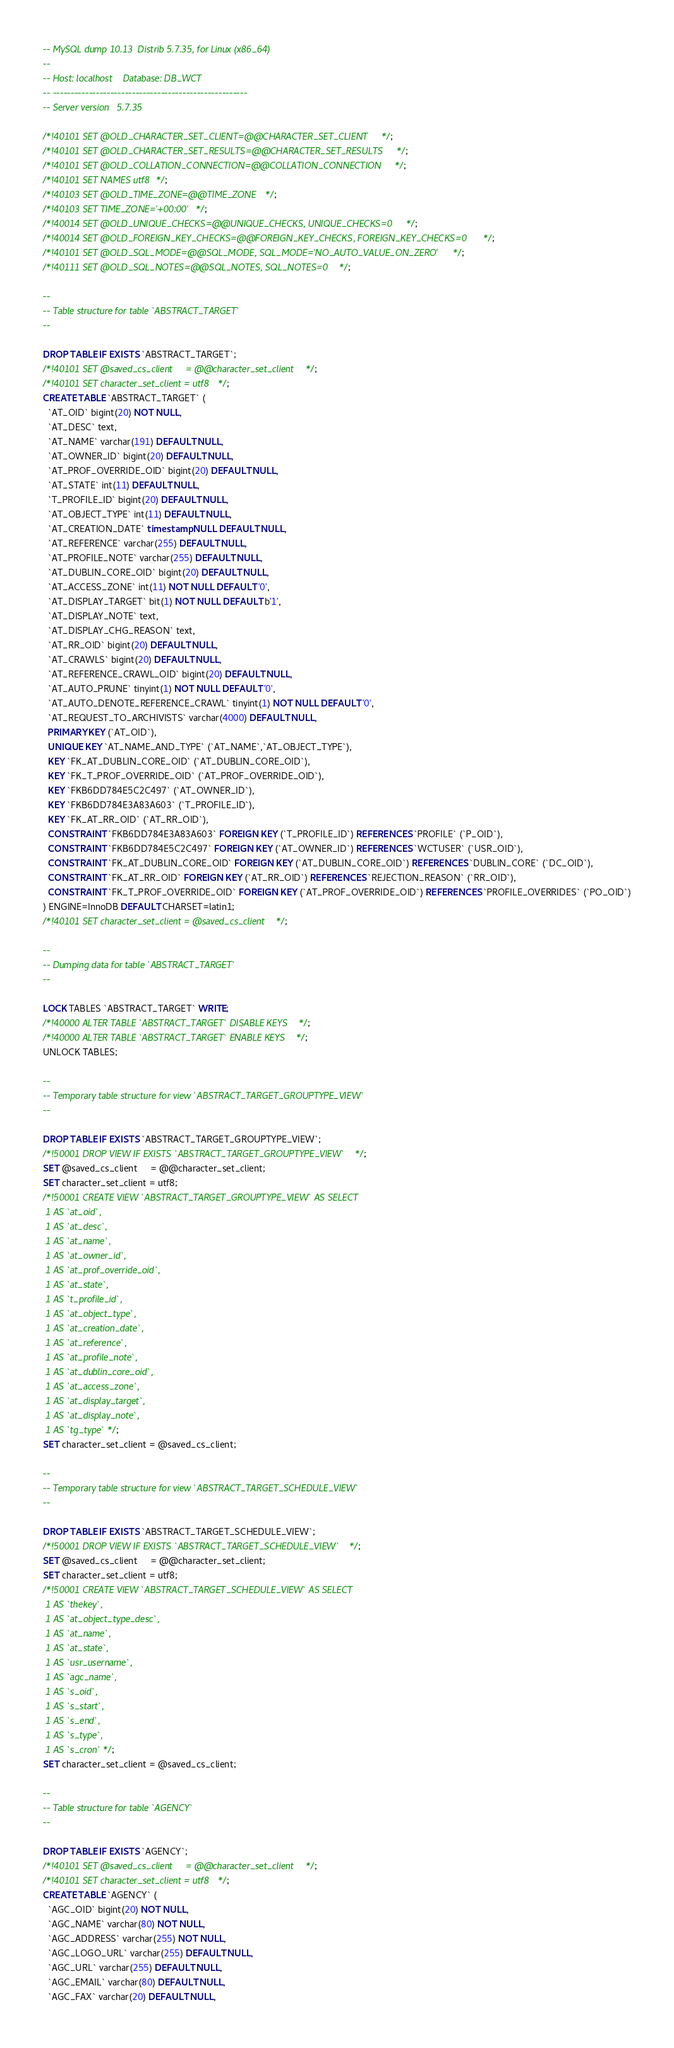Convert code to text. <code><loc_0><loc_0><loc_500><loc_500><_SQL_>-- MySQL dump 10.13  Distrib 5.7.35, for Linux (x86_64)
--
-- Host: localhost    Database: DB_WCT
-- ------------------------------------------------------
-- Server version	5.7.35

/*!40101 SET @OLD_CHARACTER_SET_CLIENT=@@CHARACTER_SET_CLIENT */;
/*!40101 SET @OLD_CHARACTER_SET_RESULTS=@@CHARACTER_SET_RESULTS */;
/*!40101 SET @OLD_COLLATION_CONNECTION=@@COLLATION_CONNECTION */;
/*!40101 SET NAMES utf8 */;
/*!40103 SET @OLD_TIME_ZONE=@@TIME_ZONE */;
/*!40103 SET TIME_ZONE='+00:00' */;
/*!40014 SET @OLD_UNIQUE_CHECKS=@@UNIQUE_CHECKS, UNIQUE_CHECKS=0 */;
/*!40014 SET @OLD_FOREIGN_KEY_CHECKS=@@FOREIGN_KEY_CHECKS, FOREIGN_KEY_CHECKS=0 */;
/*!40101 SET @OLD_SQL_MODE=@@SQL_MODE, SQL_MODE='NO_AUTO_VALUE_ON_ZERO' */;
/*!40111 SET @OLD_SQL_NOTES=@@SQL_NOTES, SQL_NOTES=0 */;

--
-- Table structure for table `ABSTRACT_TARGET`
--

DROP TABLE IF EXISTS `ABSTRACT_TARGET`;
/*!40101 SET @saved_cs_client     = @@character_set_client */;
/*!40101 SET character_set_client = utf8 */;
CREATE TABLE `ABSTRACT_TARGET` (
  `AT_OID` bigint(20) NOT NULL,
  `AT_DESC` text,
  `AT_NAME` varchar(191) DEFAULT NULL,
  `AT_OWNER_ID` bigint(20) DEFAULT NULL,
  `AT_PROF_OVERRIDE_OID` bigint(20) DEFAULT NULL,
  `AT_STATE` int(11) DEFAULT NULL,
  `T_PROFILE_ID` bigint(20) DEFAULT NULL,
  `AT_OBJECT_TYPE` int(11) DEFAULT NULL,
  `AT_CREATION_DATE` timestamp NULL DEFAULT NULL,
  `AT_REFERENCE` varchar(255) DEFAULT NULL,
  `AT_PROFILE_NOTE` varchar(255) DEFAULT NULL,
  `AT_DUBLIN_CORE_OID` bigint(20) DEFAULT NULL,
  `AT_ACCESS_ZONE` int(11) NOT NULL DEFAULT '0',
  `AT_DISPLAY_TARGET` bit(1) NOT NULL DEFAULT b'1',
  `AT_DISPLAY_NOTE` text,
  `AT_DISPLAY_CHG_REASON` text,
  `AT_RR_OID` bigint(20) DEFAULT NULL,
  `AT_CRAWLS` bigint(20) DEFAULT NULL,
  `AT_REFERENCE_CRAWL_OID` bigint(20) DEFAULT NULL,
  `AT_AUTO_PRUNE` tinyint(1) NOT NULL DEFAULT '0',
  `AT_AUTO_DENOTE_REFERENCE_CRAWL` tinyint(1) NOT NULL DEFAULT '0',
  `AT_REQUEST_TO_ARCHIVISTS` varchar(4000) DEFAULT NULL,
  PRIMARY KEY (`AT_OID`),
  UNIQUE KEY `AT_NAME_AND_TYPE` (`AT_NAME`,`AT_OBJECT_TYPE`),
  KEY `FK_AT_DUBLIN_CORE_OID` (`AT_DUBLIN_CORE_OID`),
  KEY `FK_T_PROF_OVERRIDE_OID` (`AT_PROF_OVERRIDE_OID`),
  KEY `FKB6DD784E5C2C497` (`AT_OWNER_ID`),
  KEY `FKB6DD784E3A83A603` (`T_PROFILE_ID`),
  KEY `FK_AT_RR_OID` (`AT_RR_OID`),
  CONSTRAINT `FKB6DD784E3A83A603` FOREIGN KEY (`T_PROFILE_ID`) REFERENCES `PROFILE` (`P_OID`),
  CONSTRAINT `FKB6DD784E5C2C497` FOREIGN KEY (`AT_OWNER_ID`) REFERENCES `WCTUSER` (`USR_OID`),
  CONSTRAINT `FK_AT_DUBLIN_CORE_OID` FOREIGN KEY (`AT_DUBLIN_CORE_OID`) REFERENCES `DUBLIN_CORE` (`DC_OID`),
  CONSTRAINT `FK_AT_RR_OID` FOREIGN KEY (`AT_RR_OID`) REFERENCES `REJECTION_REASON` (`RR_OID`),
  CONSTRAINT `FK_T_PROF_OVERRIDE_OID` FOREIGN KEY (`AT_PROF_OVERRIDE_OID`) REFERENCES `PROFILE_OVERRIDES` (`PO_OID`)
) ENGINE=InnoDB DEFAULT CHARSET=latin1;
/*!40101 SET character_set_client = @saved_cs_client */;

--
-- Dumping data for table `ABSTRACT_TARGET`
--

LOCK TABLES `ABSTRACT_TARGET` WRITE;
/*!40000 ALTER TABLE `ABSTRACT_TARGET` DISABLE KEYS */;
/*!40000 ALTER TABLE `ABSTRACT_TARGET` ENABLE KEYS */;
UNLOCK TABLES;

--
-- Temporary table structure for view `ABSTRACT_TARGET_GROUPTYPE_VIEW`
--

DROP TABLE IF EXISTS `ABSTRACT_TARGET_GROUPTYPE_VIEW`;
/*!50001 DROP VIEW IF EXISTS `ABSTRACT_TARGET_GROUPTYPE_VIEW`*/;
SET @saved_cs_client     = @@character_set_client;
SET character_set_client = utf8;
/*!50001 CREATE VIEW `ABSTRACT_TARGET_GROUPTYPE_VIEW` AS SELECT 
 1 AS `at_oid`,
 1 AS `at_desc`,
 1 AS `at_name`,
 1 AS `at_owner_id`,
 1 AS `at_prof_override_oid`,
 1 AS `at_state`,
 1 AS `t_profile_id`,
 1 AS `at_object_type`,
 1 AS `at_creation_date`,
 1 AS `at_reference`,
 1 AS `at_profile_note`,
 1 AS `at_dublin_core_oid`,
 1 AS `at_access_zone`,
 1 AS `at_display_target`,
 1 AS `at_display_note`,
 1 AS `tg_type`*/;
SET character_set_client = @saved_cs_client;

--
-- Temporary table structure for view `ABSTRACT_TARGET_SCHEDULE_VIEW`
--

DROP TABLE IF EXISTS `ABSTRACT_TARGET_SCHEDULE_VIEW`;
/*!50001 DROP VIEW IF EXISTS `ABSTRACT_TARGET_SCHEDULE_VIEW`*/;
SET @saved_cs_client     = @@character_set_client;
SET character_set_client = utf8;
/*!50001 CREATE VIEW `ABSTRACT_TARGET_SCHEDULE_VIEW` AS SELECT 
 1 AS `thekey`,
 1 AS `at_object_type_desc`,
 1 AS `at_name`,
 1 AS `at_state`,
 1 AS `usr_username`,
 1 AS `agc_name`,
 1 AS `s_oid`,
 1 AS `s_start`,
 1 AS `s_end`,
 1 AS `s_type`,
 1 AS `s_cron`*/;
SET character_set_client = @saved_cs_client;

--
-- Table structure for table `AGENCY`
--

DROP TABLE IF EXISTS `AGENCY`;
/*!40101 SET @saved_cs_client     = @@character_set_client */;
/*!40101 SET character_set_client = utf8 */;
CREATE TABLE `AGENCY` (
  `AGC_OID` bigint(20) NOT NULL,
  `AGC_NAME` varchar(80) NOT NULL,
  `AGC_ADDRESS` varchar(255) NOT NULL,
  `AGC_LOGO_URL` varchar(255) DEFAULT NULL,
  `AGC_URL` varchar(255) DEFAULT NULL,
  `AGC_EMAIL` varchar(80) DEFAULT NULL,
  `AGC_FAX` varchar(20) DEFAULT NULL,</code> 